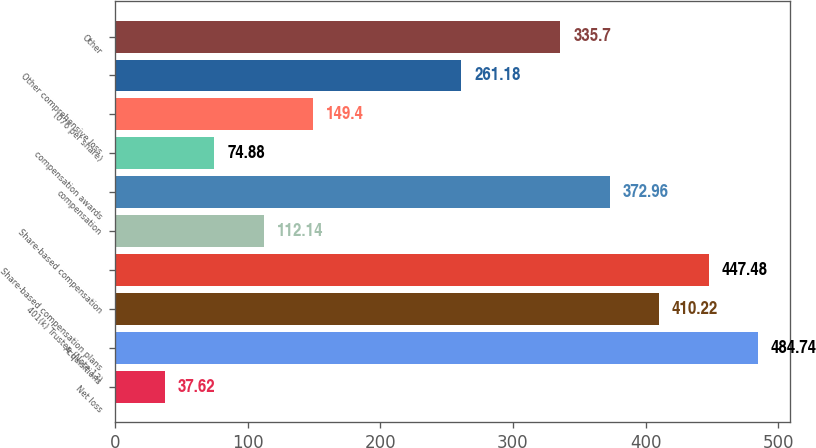Convert chart. <chart><loc_0><loc_0><loc_500><loc_500><bar_chart><fcel>Net loss<fcel>Acquisitions<fcel>401(k) Trustee (Note 13)<fcel>Share-based compensation plans<fcel>Share-based compensation<fcel>compensation<fcel>compensation awards<fcel>(076 per share)<fcel>Other comprehensive loss<fcel>Other<nl><fcel>37.62<fcel>484.74<fcel>410.22<fcel>447.48<fcel>112.14<fcel>372.96<fcel>74.88<fcel>149.4<fcel>261.18<fcel>335.7<nl></chart> 